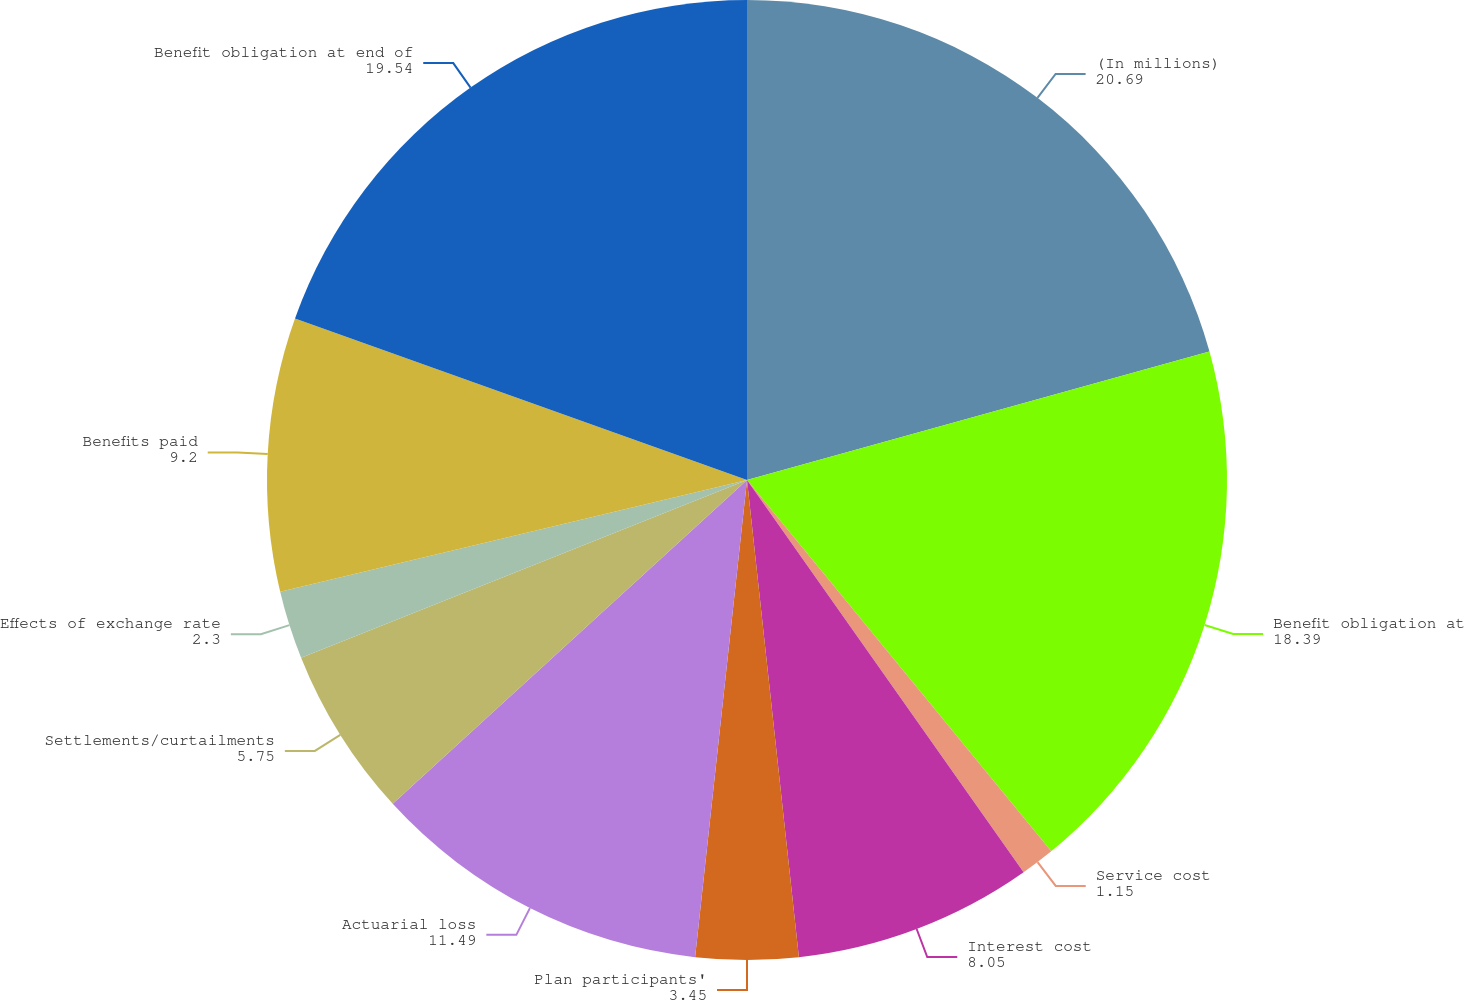Convert chart. <chart><loc_0><loc_0><loc_500><loc_500><pie_chart><fcel>(In millions)<fcel>Benefit obligation at<fcel>Service cost<fcel>Interest cost<fcel>Plan participants'<fcel>Actuarial loss<fcel>Settlements/curtailments<fcel>Effects of exchange rate<fcel>Benefits paid<fcel>Benefit obligation at end of<nl><fcel>20.69%<fcel>18.39%<fcel>1.15%<fcel>8.05%<fcel>3.45%<fcel>11.49%<fcel>5.75%<fcel>2.3%<fcel>9.2%<fcel>19.54%<nl></chart> 